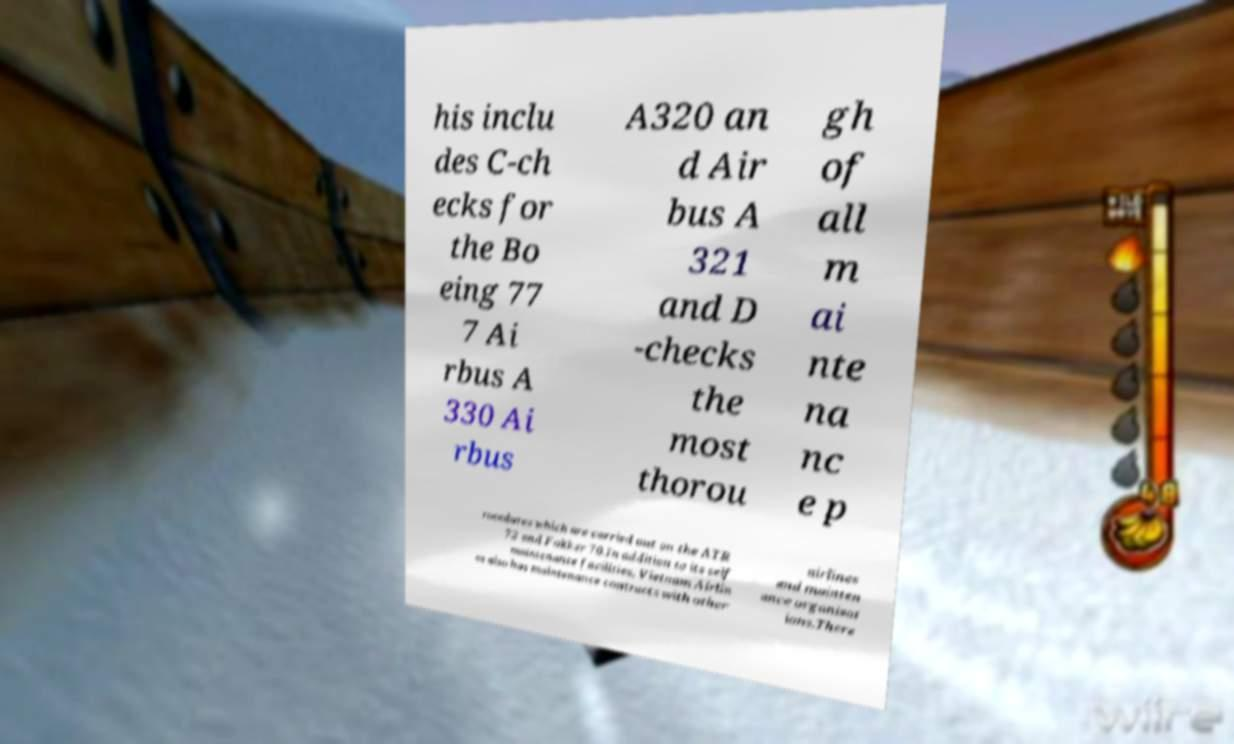For documentation purposes, I need the text within this image transcribed. Could you provide that? his inclu des C-ch ecks for the Bo eing 77 7 Ai rbus A 330 Ai rbus A320 an d Air bus A 321 and D -checks the most thorou gh of all m ai nte na nc e p rocedures which are carried out on the ATR 72 and Fokker 70.In addition to its self maintenance facilities, Vietnam Airlin es also has maintenance contracts with other airlines and mainten ance organisat ions.There 